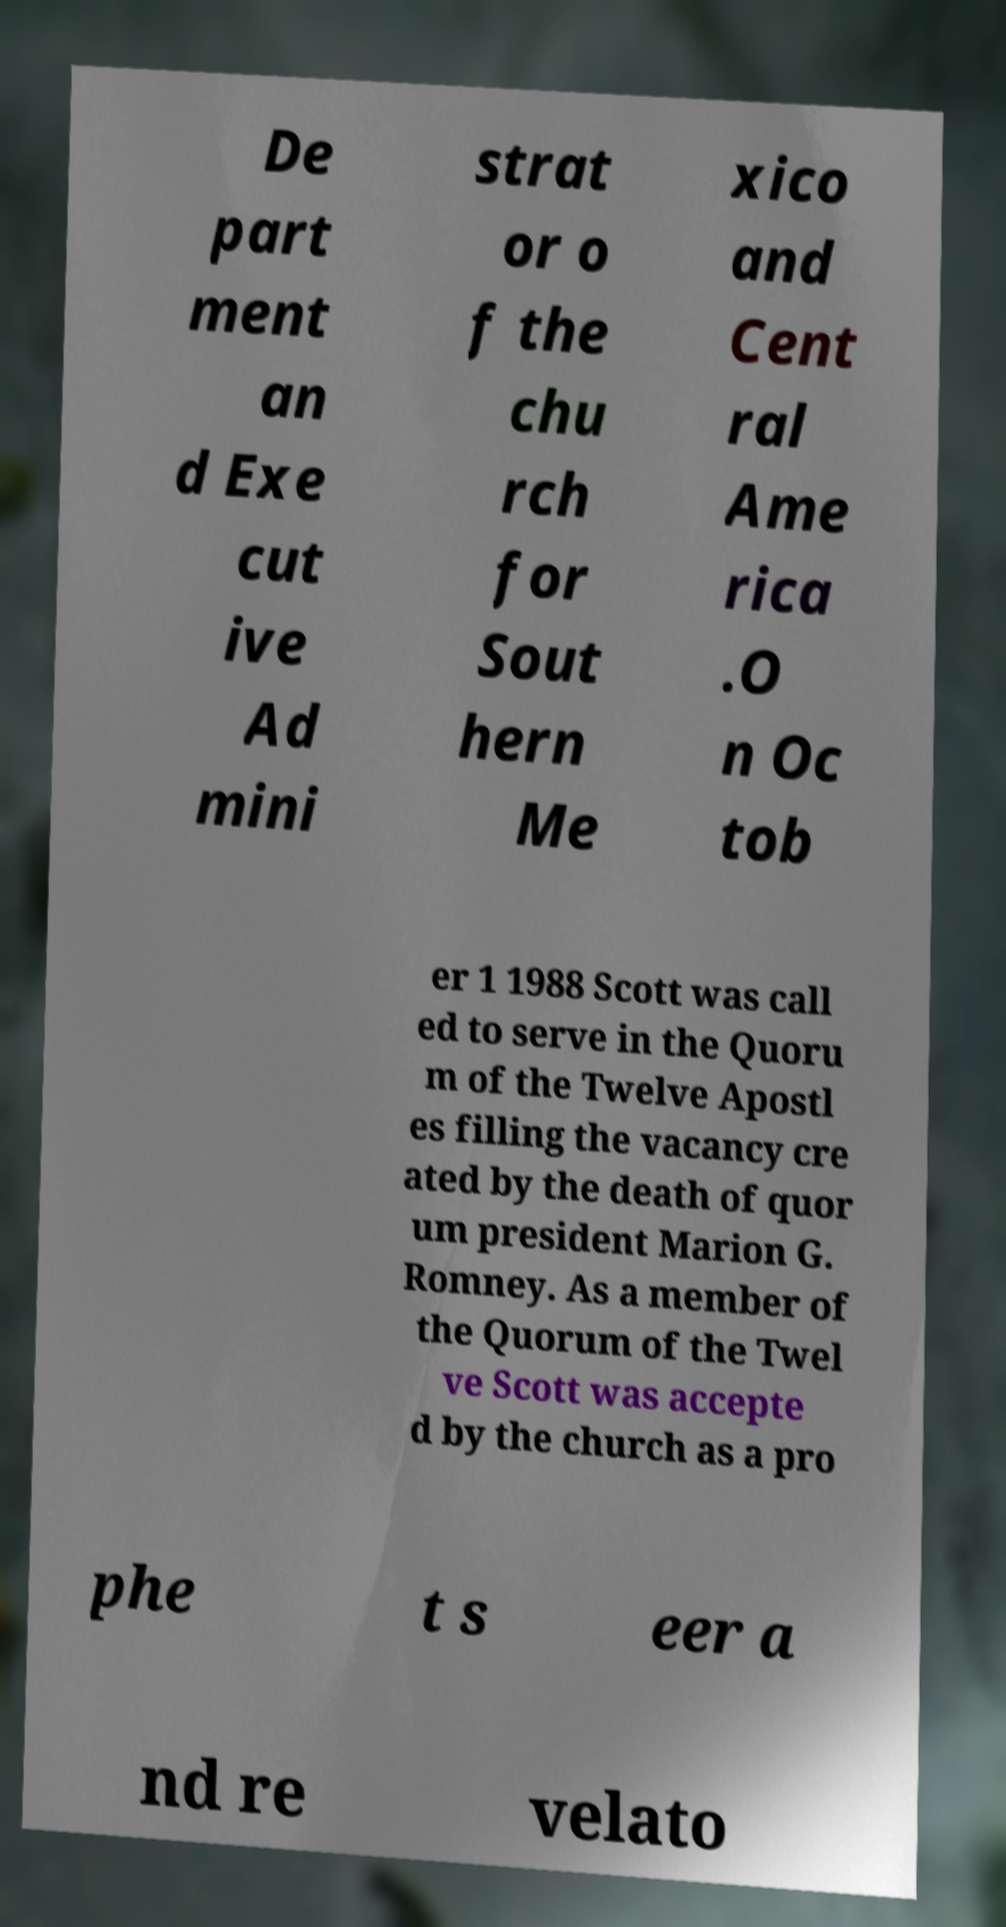Could you assist in decoding the text presented in this image and type it out clearly? De part ment an d Exe cut ive Ad mini strat or o f the chu rch for Sout hern Me xico and Cent ral Ame rica .O n Oc tob er 1 1988 Scott was call ed to serve in the Quoru m of the Twelve Apostl es filling the vacancy cre ated by the death of quor um president Marion G. Romney. As a member of the Quorum of the Twel ve Scott was accepte d by the church as a pro phe t s eer a nd re velato 